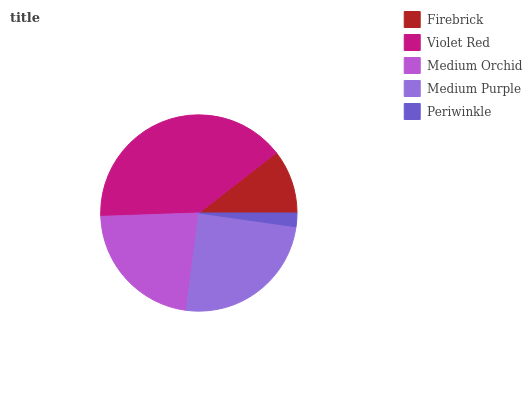Is Periwinkle the minimum?
Answer yes or no. Yes. Is Violet Red the maximum?
Answer yes or no. Yes. Is Medium Orchid the minimum?
Answer yes or no. No. Is Medium Orchid the maximum?
Answer yes or no. No. Is Violet Red greater than Medium Orchid?
Answer yes or no. Yes. Is Medium Orchid less than Violet Red?
Answer yes or no. Yes. Is Medium Orchid greater than Violet Red?
Answer yes or no. No. Is Violet Red less than Medium Orchid?
Answer yes or no. No. Is Medium Orchid the high median?
Answer yes or no. Yes. Is Medium Orchid the low median?
Answer yes or no. Yes. Is Violet Red the high median?
Answer yes or no. No. Is Violet Red the low median?
Answer yes or no. No. 